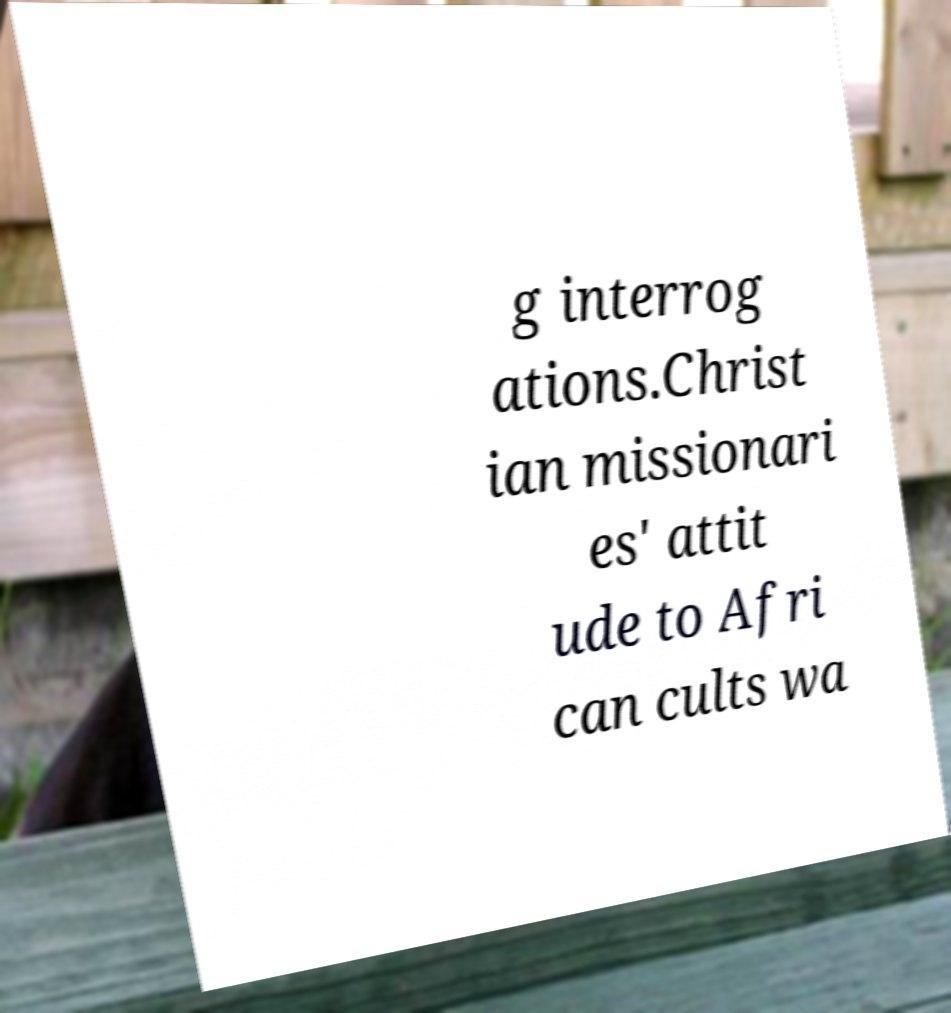Please read and relay the text visible in this image. What does it say? g interrog ations.Christ ian missionari es' attit ude to Afri can cults wa 